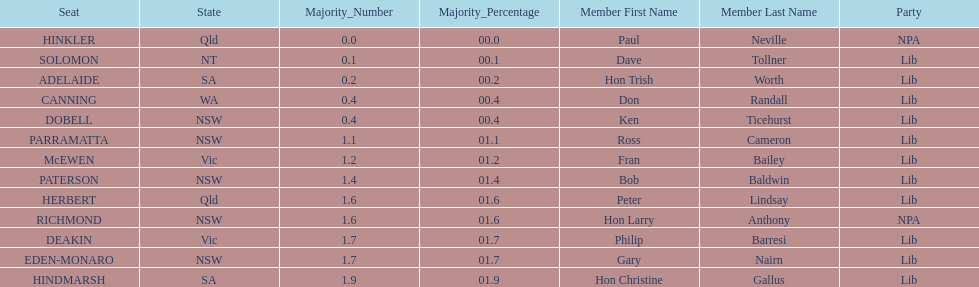What member comes next after hon trish worth? Don Randall. 